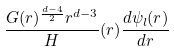<formula> <loc_0><loc_0><loc_500><loc_500>\frac { G ( r ) ^ { \frac { d - 4 } { 2 } } r ^ { d - 3 } } H ( r ) \frac { d \psi _ { l } ( r ) } { d r }</formula> 